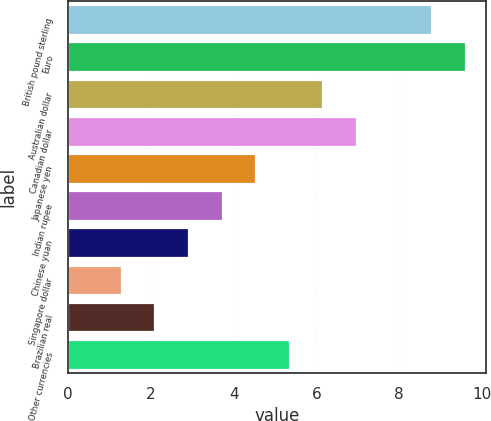Convert chart to OTSL. <chart><loc_0><loc_0><loc_500><loc_500><bar_chart><fcel>British pound sterling<fcel>Euro<fcel>Australian dollar<fcel>Canadian dollar<fcel>Japanese yen<fcel>Indian rupee<fcel>Chinese yuan<fcel>Singapore dollar<fcel>Brazilian real<fcel>Other currencies<nl><fcel>8.8<fcel>9.61<fcel>6.16<fcel>6.97<fcel>4.54<fcel>3.73<fcel>2.92<fcel>1.3<fcel>2.11<fcel>5.35<nl></chart> 